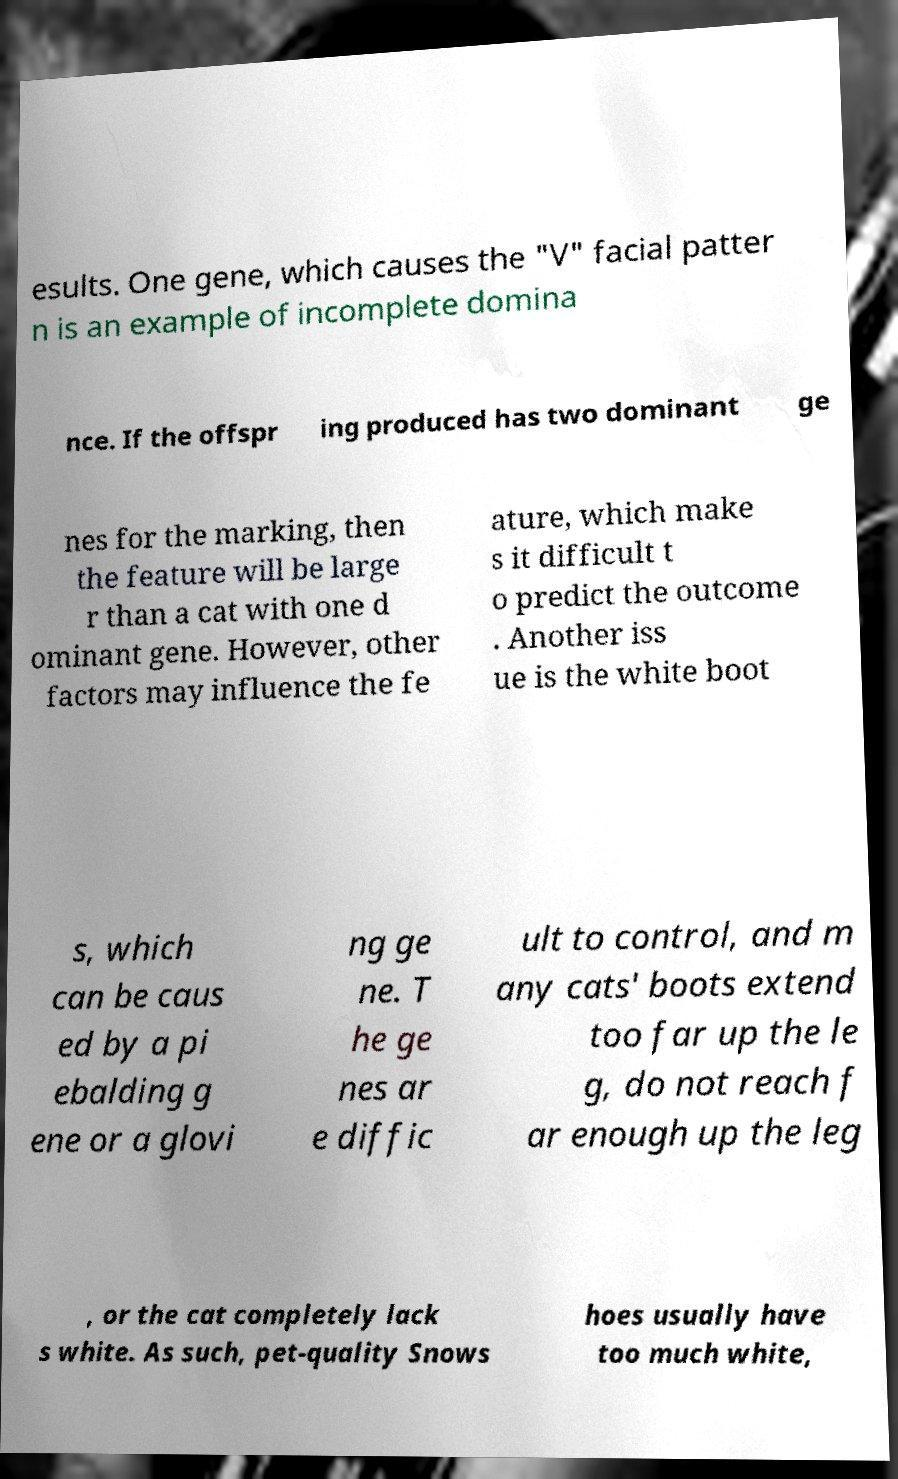Can you read and provide the text displayed in the image?This photo seems to have some interesting text. Can you extract and type it out for me? esults. One gene, which causes the "V" facial patter n is an example of incomplete domina nce. If the offspr ing produced has two dominant ge nes for the marking, then the feature will be large r than a cat with one d ominant gene. However, other factors may influence the fe ature, which make s it difficult t o predict the outcome . Another iss ue is the white boot s, which can be caus ed by a pi ebalding g ene or a glovi ng ge ne. T he ge nes ar e diffic ult to control, and m any cats' boots extend too far up the le g, do not reach f ar enough up the leg , or the cat completely lack s white. As such, pet-quality Snows hoes usually have too much white, 